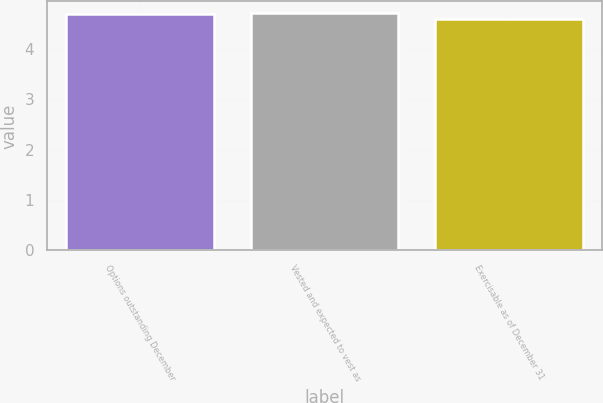Convert chart to OTSL. <chart><loc_0><loc_0><loc_500><loc_500><bar_chart><fcel>Options outstanding December<fcel>Vested and expected to vest as<fcel>Exercisable as of December 31<nl><fcel>4.7<fcel>4.71<fcel>4.6<nl></chart> 